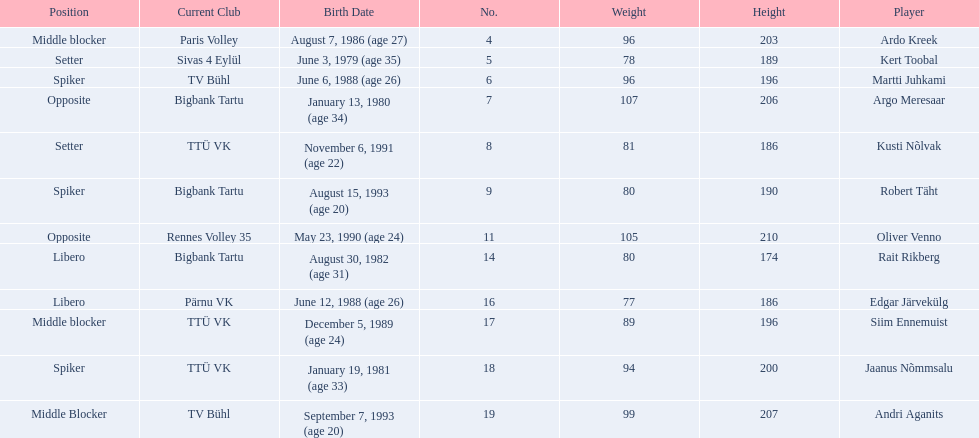Who are all of the players? Ardo Kreek, Kert Toobal, Martti Juhkami, Argo Meresaar, Kusti Nõlvak, Robert Täht, Oliver Venno, Rait Rikberg, Edgar Järvekülg, Siim Ennemuist, Jaanus Nõmmsalu, Andri Aganits. How tall are they? 203, 189, 196, 206, 186, 190, 210, 174, 186, 196, 200, 207. And which player is tallest? Oliver Venno. 